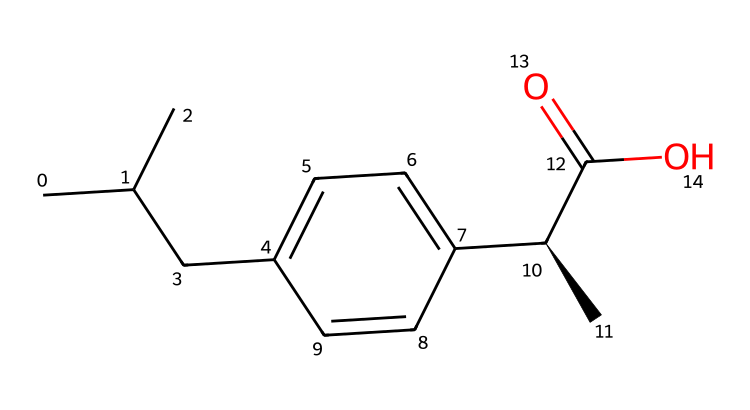What is the molecular formula of ibuprofen? In the provided SMILES representation, we can count the different types of atoms present in the structure. In this case, there are 13 carbon (C) atoms, 18 hydrogen (H) atoms, and 2 oxygen (O) atoms, giving us a molecular formula of C13H18O2.
Answer: C13H18O2 How many rings are present in the structure? By analyzing the SMILES, we can see that there are only linear chains and no cyclic structures indicated. Therefore, the number of rings in ibuprofen is zero.
Answer: 0 What is the functional group present in ibuprofen? Looking at the structure, the group –COOH (carboxylic acid) can be identified at the end of the carbon chain, indicating that the functional group present in ibuprofen is a carboxylic acid.
Answer: carboxylic acid How many stereocenters are there in ibuprofen? The presence of a chiral center can be identified from the '@' symbol in the SMILES, indicating that iverbuprofen has one stereocenter, specifically at the carbon attached to the –C(=O)O group.
Answer: 1 What is the typical use of ibuprofen? Given the context that suggests this chemical is related to travel-related aches and pains, ibuprofen is commonly used as a nonsteroidal anti-inflammatory drug (NSAID) to relieve pain.
Answer: pain relief Does ibuprofen contain any heteroatoms? In the structure represented by the SMILES, we observe the presence of oxygen (O) atoms. Since oxygen is not a carbon or hydrogen atom, we classify it as a heteroatom.
Answer: yes 